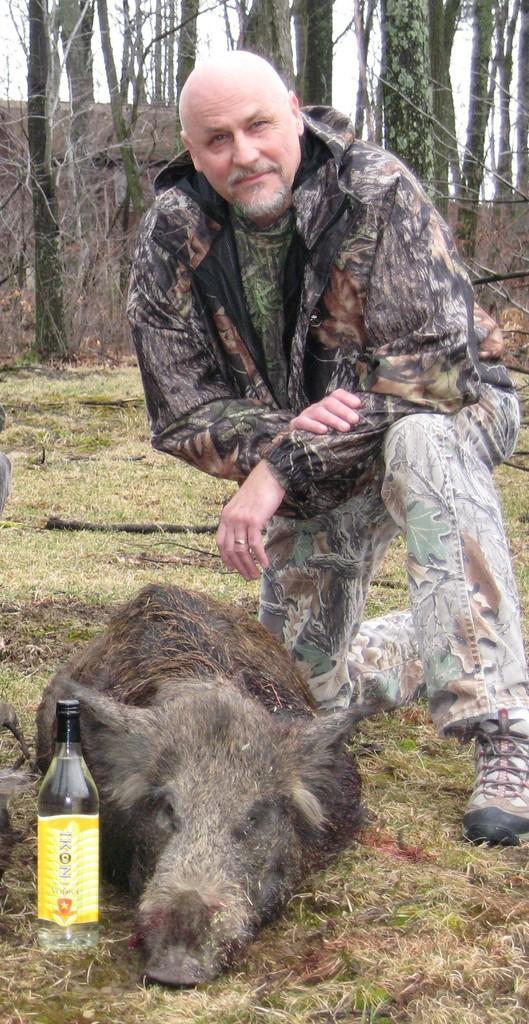How would you summarize this image in a sentence or two? in this Picture we can see a person with bald head wearing jacket, track and woodland shoe seeing in front of the camera, and a pig lying down on the ground, and a beer bottle at the left corner. Behind we can see tree and dry branches. 